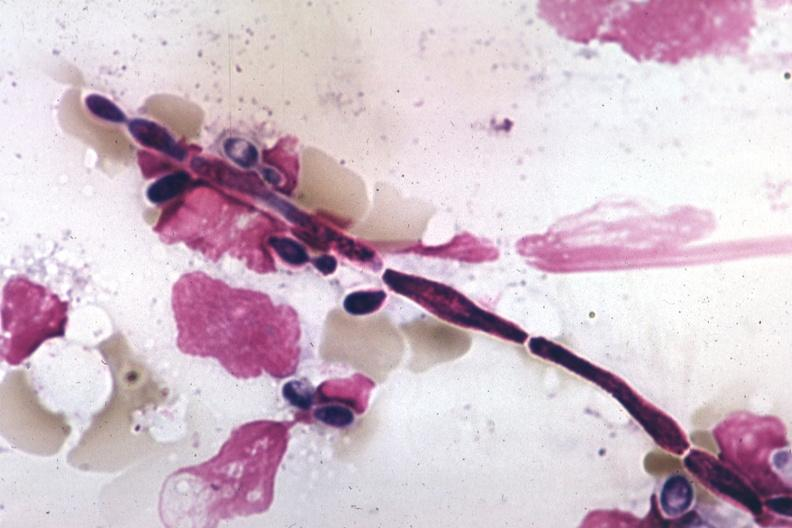s blood present?
Answer the question using a single word or phrase. Yes 